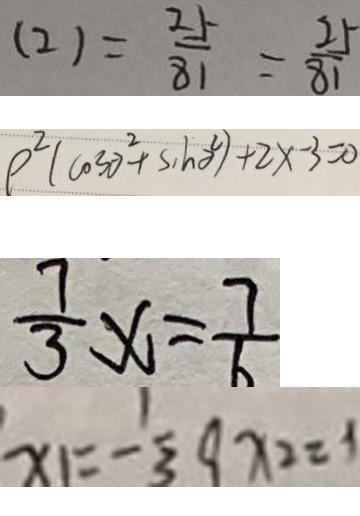<formula> <loc_0><loc_0><loc_500><loc_500>( 2 ) = \frac { 2 5 } { 8 1 } = \frac { 2 5 } { 8 1 } 
 \rho ^ { 2 } ( \cos \theta ^ { 2 } + \sin \theta ^ { 2 } ) + 2 x - 3 = 0 
 \frac { 7 } { 3 } x = \frac { 7 } { 6 } 
 x _ { 1 } = - \frac { 1 } { 3 } 9 x _ { 2 } = 1</formula> 